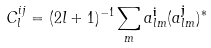<formula> <loc_0><loc_0><loc_500><loc_500>C ^ { i j } _ { l } = ( 2 l + 1 ) ^ { - 1 } \sum _ { m } a _ { l m } ^ { \mathbf i } ( a _ { l m } ^ { \mathbf j } ) ^ { * }</formula> 